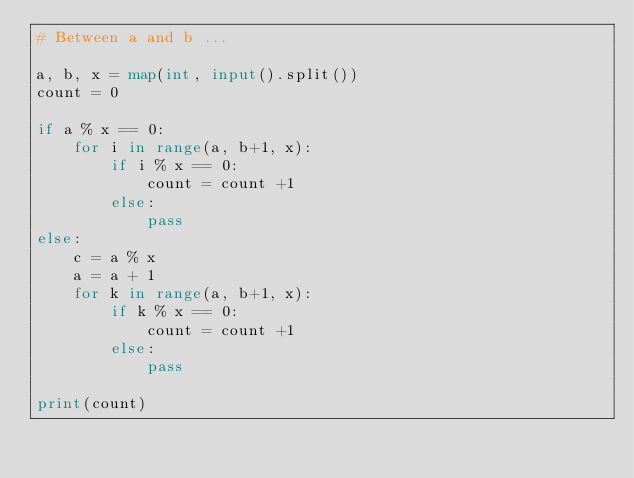<code> <loc_0><loc_0><loc_500><loc_500><_Python_># Between a and b ...

a, b, x = map(int, input().split())
count = 0

if a % x == 0:
    for i in range(a, b+1, x):
        if i % x == 0:
            count = count +1
        else:
            pass
else:
    c = a % x
    a = a + 1
    for k in range(a, b+1, x):
        if k % x == 0:
            count = count +1
        else:
            pass
        
print(count)
</code> 